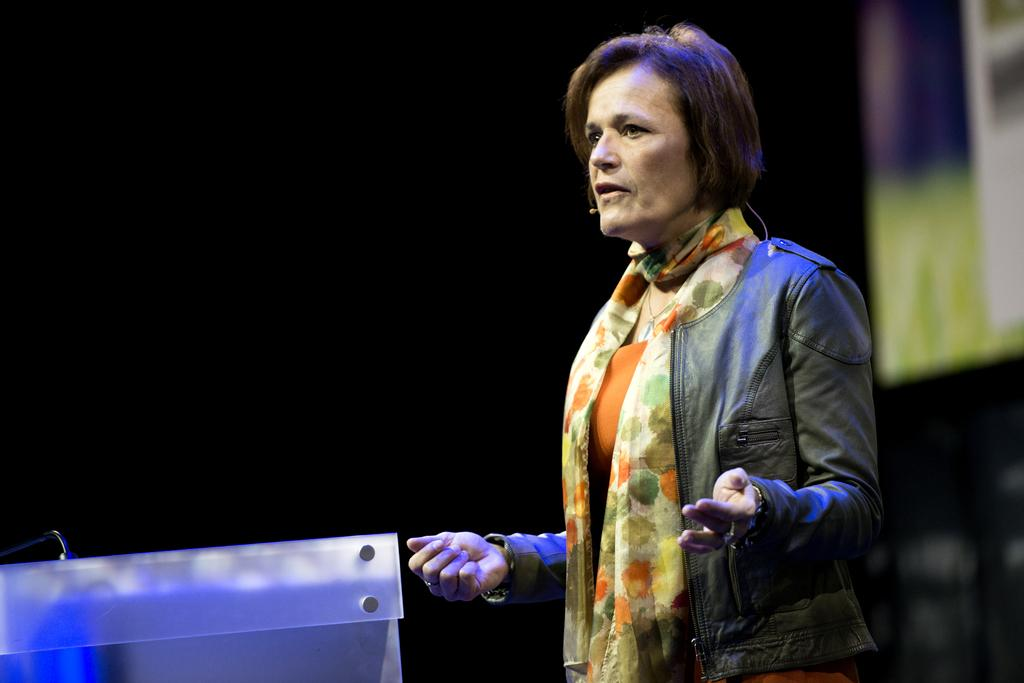What is the main subject of the image? There is a woman standing in the center of the image. What is the woman doing in the image? The woman is speaking. What is in front of the woman in the image? There is a stand in front of the woman. What is the color of the stand? The stand is white in color. How would you describe the background of the image? The background of the image is blurry. How many muscles can be seen flexing in the woman's arm in the image? There is no indication of the woman's muscles in the image, so it is not possible to determine how many are flexing. 